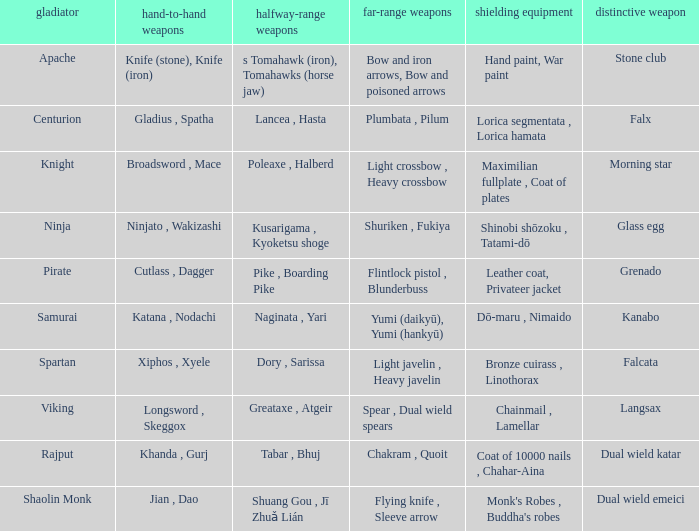If the armor is bronze cuirass , linothorax, what are the close ranged weapons? Xiphos , Xyele. 